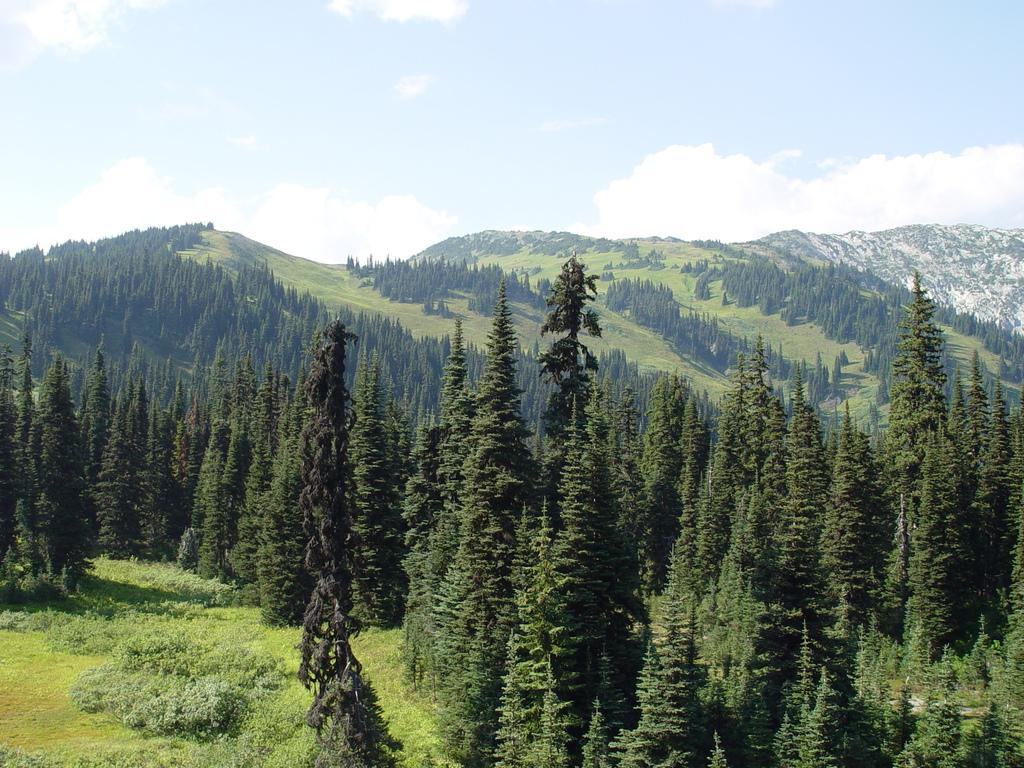What type of terrain is visible in the image? There is ground visible in the image. What natural features can be seen on the ground? There are many trees in the image. What can be seen in the distance in the image? There are mountains in the background of the image. What else is visible in the background of the image? There are clouds and the sky in the background of the image. What mathematical operation is being performed on the table in the image? There is no table or mathematical operation present in the image. 